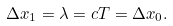Convert formula to latex. <formula><loc_0><loc_0><loc_500><loc_500>\Delta x _ { 1 } = \lambda = c T = \Delta x _ { 0 } .</formula> 